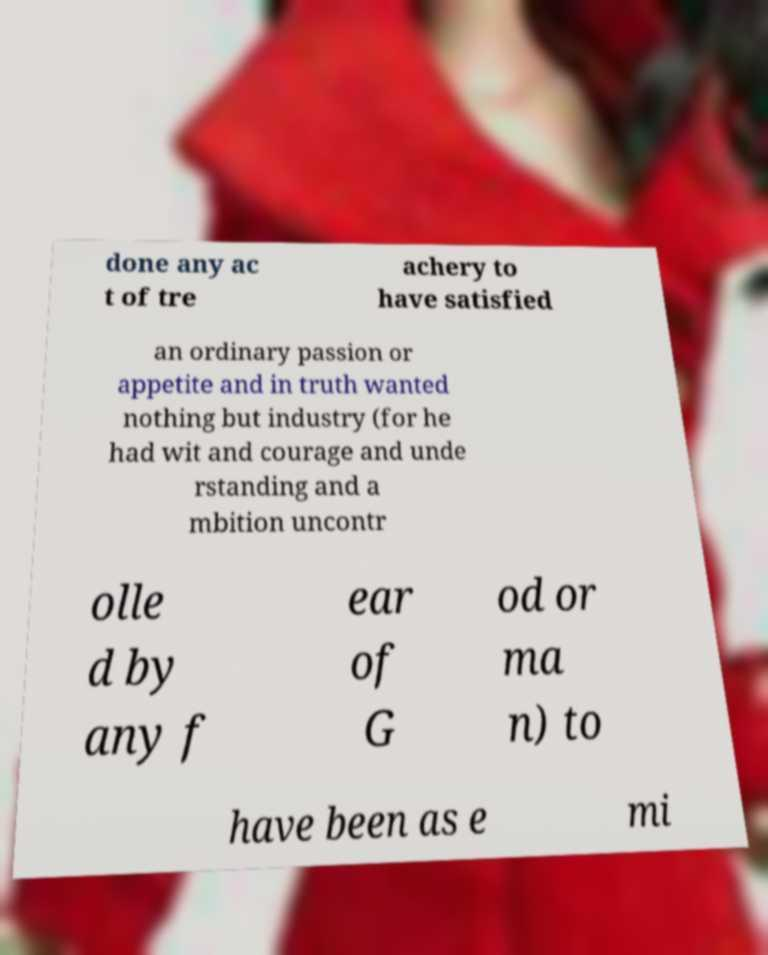Can you read and provide the text displayed in the image?This photo seems to have some interesting text. Can you extract and type it out for me? done any ac t of tre achery to have satisfied an ordinary passion or appetite and in truth wanted nothing but industry (for he had wit and courage and unde rstanding and a mbition uncontr olle d by any f ear of G od or ma n) to have been as e mi 